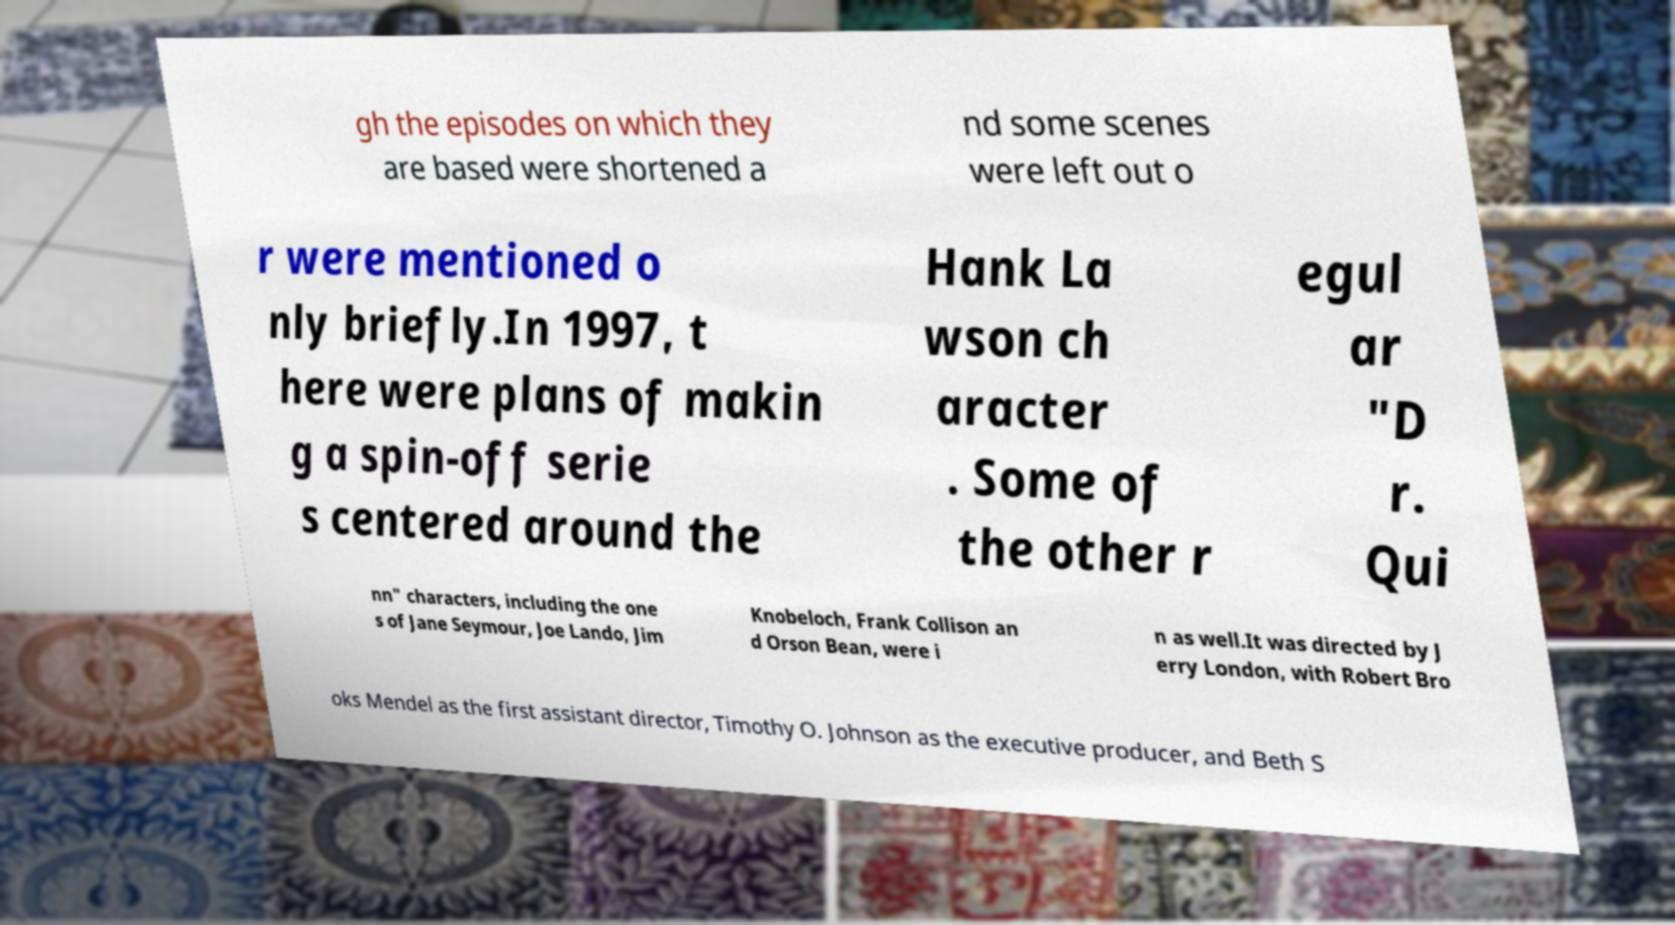Can you accurately transcribe the text from the provided image for me? gh the episodes on which they are based were shortened a nd some scenes were left out o r were mentioned o nly briefly.In 1997, t here were plans of makin g a spin-off serie s centered around the Hank La wson ch aracter . Some of the other r egul ar "D r. Qui nn" characters, including the one s of Jane Seymour, Joe Lando, Jim Knobeloch, Frank Collison an d Orson Bean, were i n as well.It was directed by J erry London, with Robert Bro oks Mendel as the first assistant director, Timothy O. Johnson as the executive producer, and Beth S 